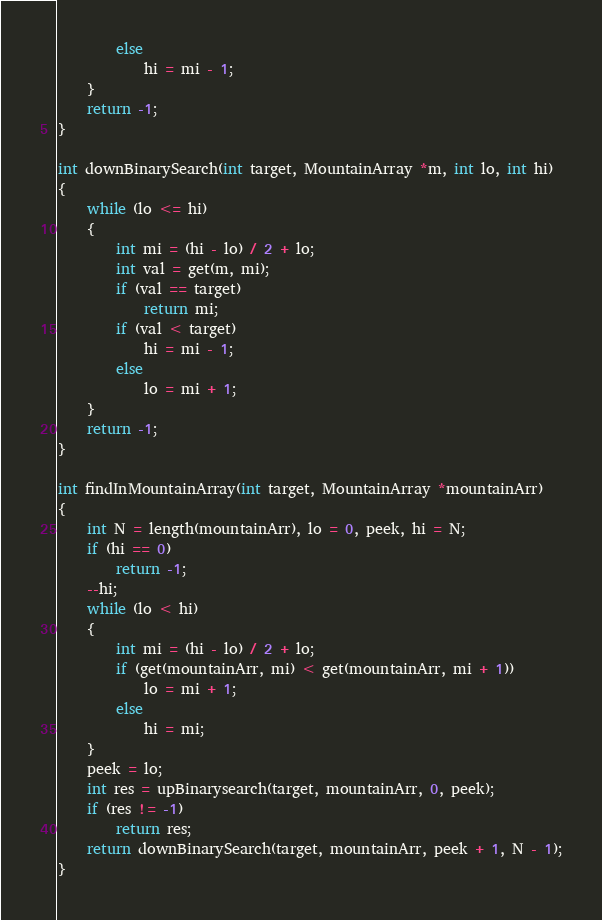<code> <loc_0><loc_0><loc_500><loc_500><_C_>		else
			hi = mi - 1;
	}
	return -1;
}

int downBinarySearch(int target, MountainArray *m, int lo, int hi)
{
	while (lo <= hi)
	{
		int mi = (hi - lo) / 2 + lo;
		int val = get(m, mi);
		if (val == target)
			return mi;
		if (val < target)
			hi = mi - 1;
		else
			lo = mi + 1;
	}
	return -1;
}

int findInMountainArray(int target, MountainArray *mountainArr)
{
	int N = length(mountainArr), lo = 0, peek, hi = N;
	if (hi == 0)
		return -1;
	--hi;
	while (lo < hi)
	{
		int mi = (hi - lo) / 2 + lo;
		if (get(mountainArr, mi) < get(mountainArr, mi + 1))
			lo = mi + 1;
		else
			hi = mi;
	}
	peek = lo;
	int res = upBinarysearch(target, mountainArr, 0, peek);
	if (res != -1)
		return res;
	return downBinarySearch(target, mountainArr, peek + 1, N - 1);
}</code> 